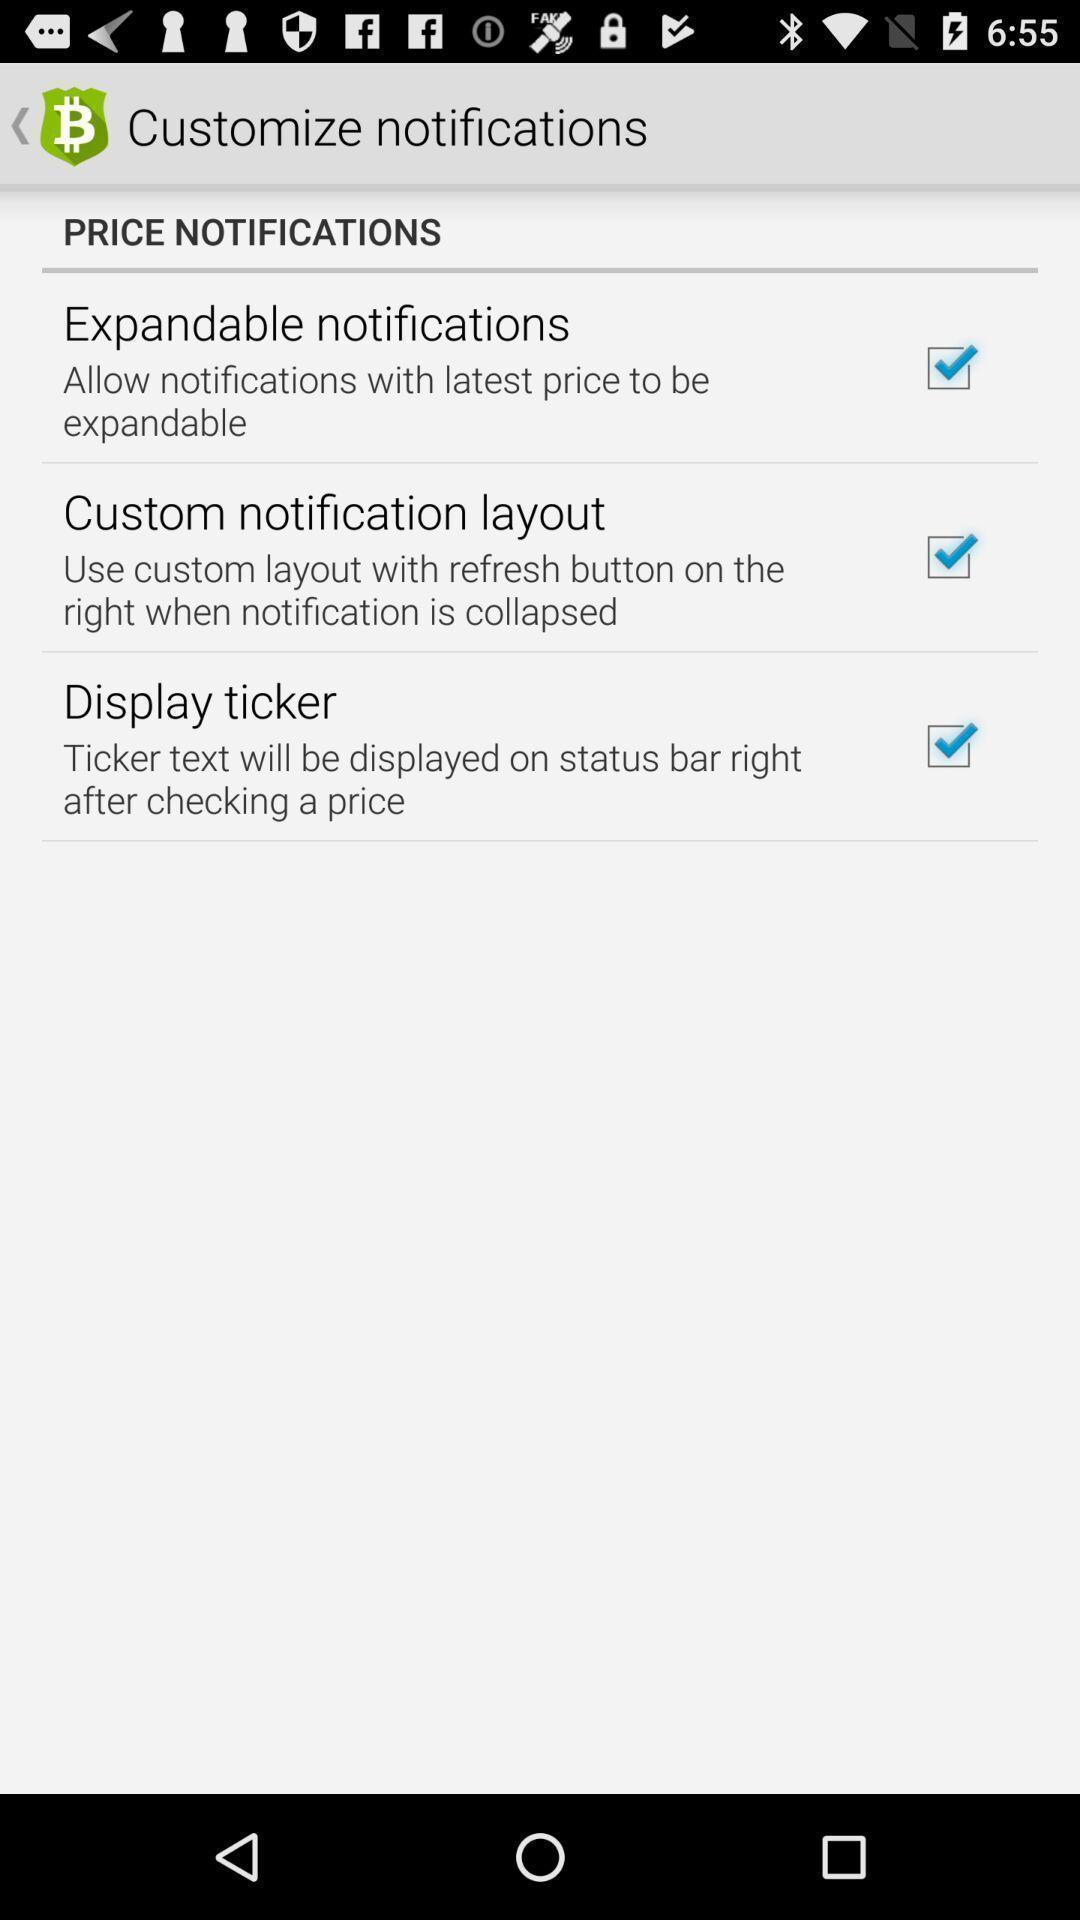Describe the key features of this screenshot. Page showing notifications permission in app. 